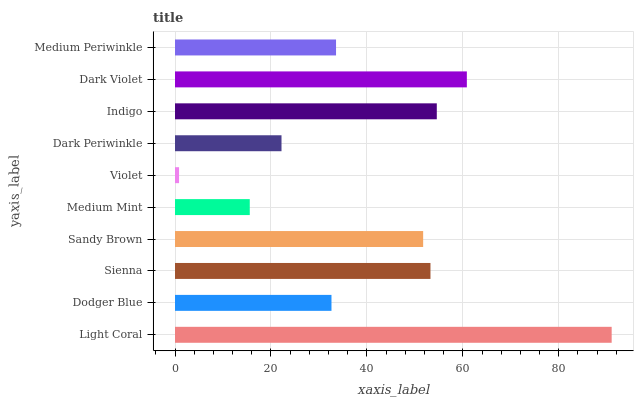Is Violet the minimum?
Answer yes or no. Yes. Is Light Coral the maximum?
Answer yes or no. Yes. Is Dodger Blue the minimum?
Answer yes or no. No. Is Dodger Blue the maximum?
Answer yes or no. No. Is Light Coral greater than Dodger Blue?
Answer yes or no. Yes. Is Dodger Blue less than Light Coral?
Answer yes or no. Yes. Is Dodger Blue greater than Light Coral?
Answer yes or no. No. Is Light Coral less than Dodger Blue?
Answer yes or no. No. Is Sandy Brown the high median?
Answer yes or no. Yes. Is Medium Periwinkle the low median?
Answer yes or no. Yes. Is Dark Violet the high median?
Answer yes or no. No. Is Dark Periwinkle the low median?
Answer yes or no. No. 